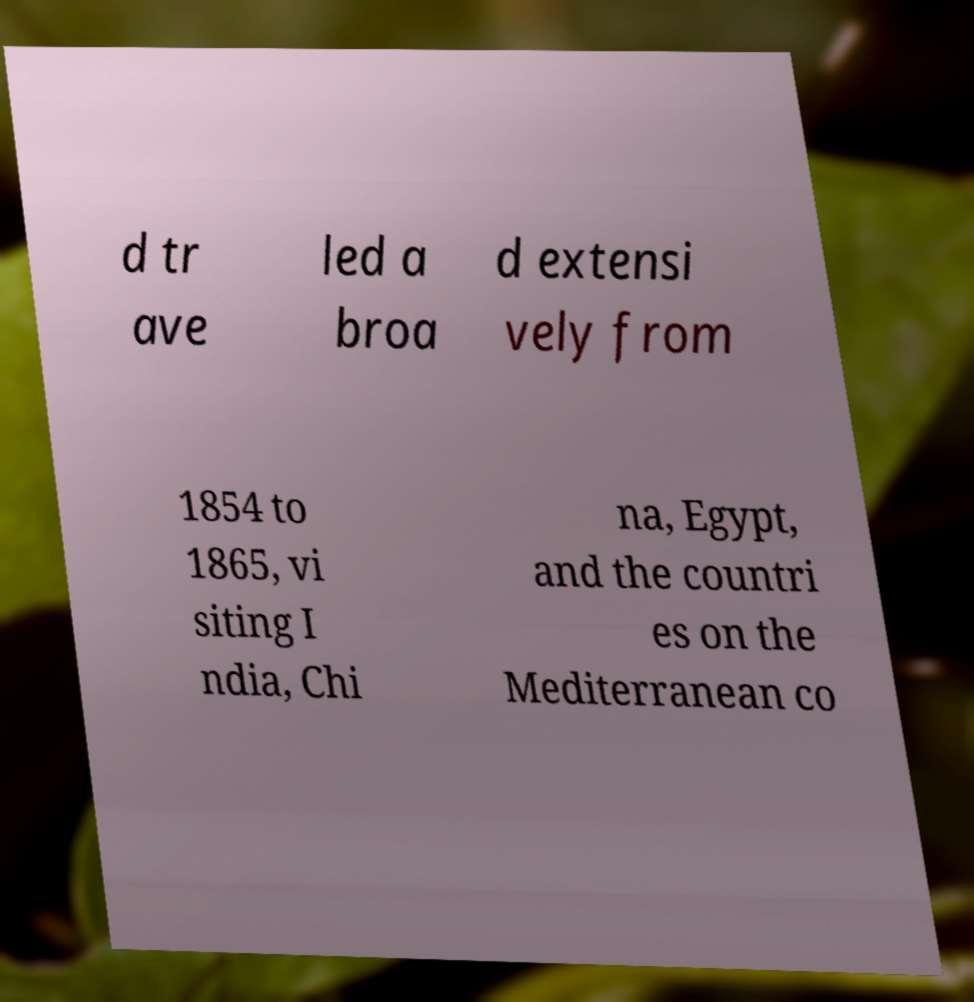Could you assist in decoding the text presented in this image and type it out clearly? d tr ave led a broa d extensi vely from 1854 to 1865, vi siting I ndia, Chi na, Egypt, and the countri es on the Mediterranean co 